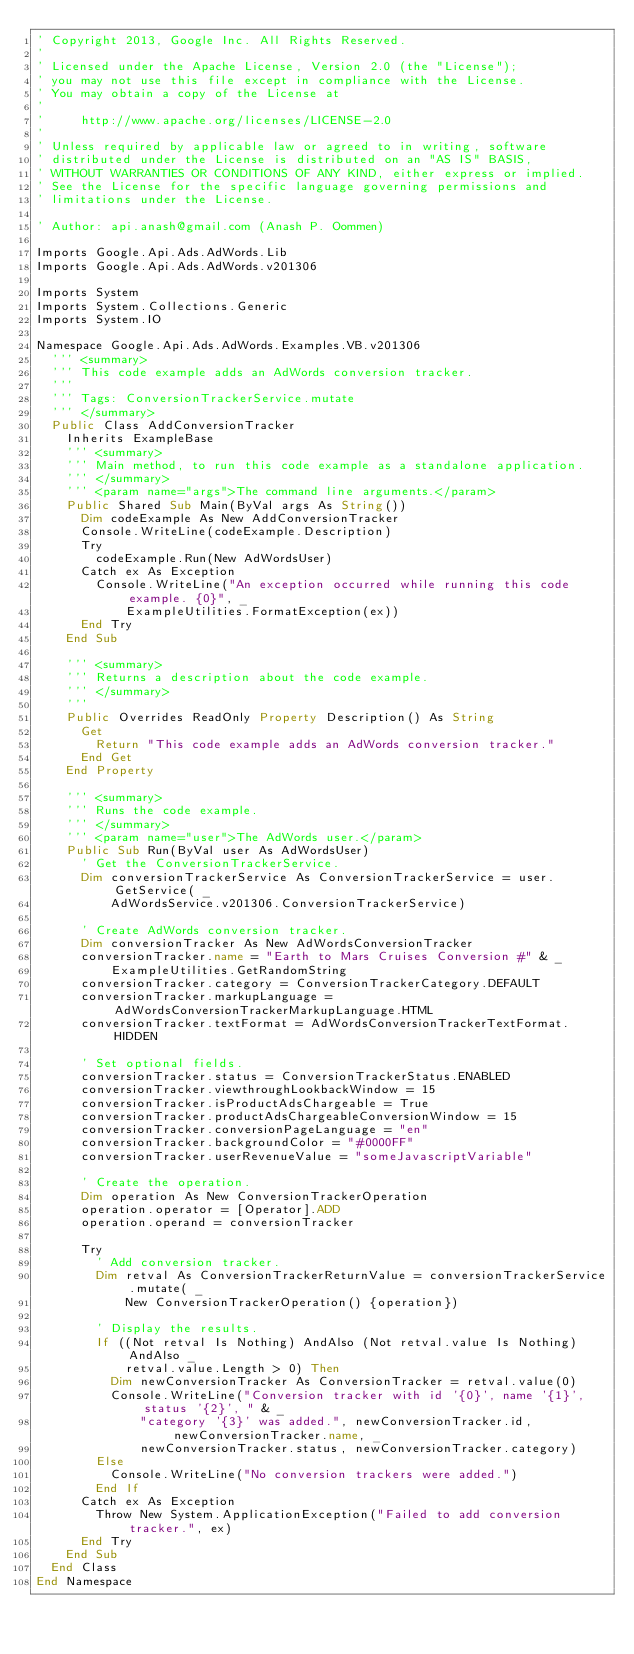Convert code to text. <code><loc_0><loc_0><loc_500><loc_500><_VisualBasic_>' Copyright 2013, Google Inc. All Rights Reserved.
'
' Licensed under the Apache License, Version 2.0 (the "License");
' you may not use this file except in compliance with the License.
' You may obtain a copy of the License at
'
'     http://www.apache.org/licenses/LICENSE-2.0
'
' Unless required by applicable law or agreed to in writing, software
' distributed under the License is distributed on an "AS IS" BASIS,
' WITHOUT WARRANTIES OR CONDITIONS OF ANY KIND, either express or implied.
' See the License for the specific language governing permissions and
' limitations under the License.

' Author: api.anash@gmail.com (Anash P. Oommen)

Imports Google.Api.Ads.AdWords.Lib
Imports Google.Api.Ads.AdWords.v201306

Imports System
Imports System.Collections.Generic
Imports System.IO

Namespace Google.Api.Ads.AdWords.Examples.VB.v201306
  ''' <summary>
  ''' This code example adds an AdWords conversion tracker.
  '''
  ''' Tags: ConversionTrackerService.mutate
  ''' </summary>
  Public Class AddConversionTracker
    Inherits ExampleBase
    ''' <summary>
    ''' Main method, to run this code example as a standalone application.
    ''' </summary>
    ''' <param name="args">The command line arguments.</param>
    Public Shared Sub Main(ByVal args As String())
      Dim codeExample As New AddConversionTracker
      Console.WriteLine(codeExample.Description)
      Try
        codeExample.Run(New AdWordsUser)
      Catch ex As Exception
        Console.WriteLine("An exception occurred while running this code example. {0}", _
            ExampleUtilities.FormatException(ex))
      End Try
    End Sub

    ''' <summary>
    ''' Returns a description about the code example.
    ''' </summary>
    '''
    Public Overrides ReadOnly Property Description() As String
      Get
        Return "This code example adds an AdWords conversion tracker."
      End Get
    End Property

    ''' <summary>
    ''' Runs the code example.
    ''' </summary>
    ''' <param name="user">The AdWords user.</param>
    Public Sub Run(ByVal user As AdWordsUser)
      ' Get the ConversionTrackerService.
      Dim conversionTrackerService As ConversionTrackerService = user.GetService( _
          AdWordsService.v201306.ConversionTrackerService)

      ' Create AdWords conversion tracker.
      Dim conversionTracker As New AdWordsConversionTracker
      conversionTracker.name = "Earth to Mars Cruises Conversion #" & _
          ExampleUtilities.GetRandomString
      conversionTracker.category = ConversionTrackerCategory.DEFAULT
      conversionTracker.markupLanguage = AdWordsConversionTrackerMarkupLanguage.HTML
      conversionTracker.textFormat = AdWordsConversionTrackerTextFormat.HIDDEN

      ' Set optional fields.
      conversionTracker.status = ConversionTrackerStatus.ENABLED
      conversionTracker.viewthroughLookbackWindow = 15
      conversionTracker.isProductAdsChargeable = True
      conversionTracker.productAdsChargeableConversionWindow = 15
      conversionTracker.conversionPageLanguage = "en"
      conversionTracker.backgroundColor = "#0000FF"
      conversionTracker.userRevenueValue = "someJavascriptVariable"

      ' Create the operation.
      Dim operation As New ConversionTrackerOperation
      operation.operator = [Operator].ADD
      operation.operand = conversionTracker

      Try
        ' Add conversion tracker.
        Dim retval As ConversionTrackerReturnValue = conversionTrackerService.mutate( _
            New ConversionTrackerOperation() {operation})

        ' Display the results.
        If ((Not retval Is Nothing) AndAlso (Not retval.value Is Nothing) AndAlso _
            retval.value.Length > 0) Then
          Dim newConversionTracker As ConversionTracker = retval.value(0)
          Console.WriteLine("Conversion tracker with id '{0}', name '{1}', status '{2}', " & _
              "category '{3}' was added.", newConversionTracker.id, newConversionTracker.name, _
              newConversionTracker.status, newConversionTracker.category)
        Else
          Console.WriteLine("No conversion trackers were added.")
        End If
      Catch ex As Exception
        Throw New System.ApplicationException("Failed to add conversion tracker.", ex)
      End Try
    End Sub
  End Class
End Namespace
</code> 